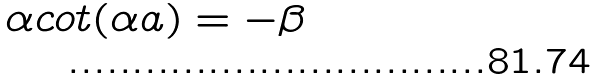<formula> <loc_0><loc_0><loc_500><loc_500>\alpha c o t ( \alpha a ) = - \beta</formula> 